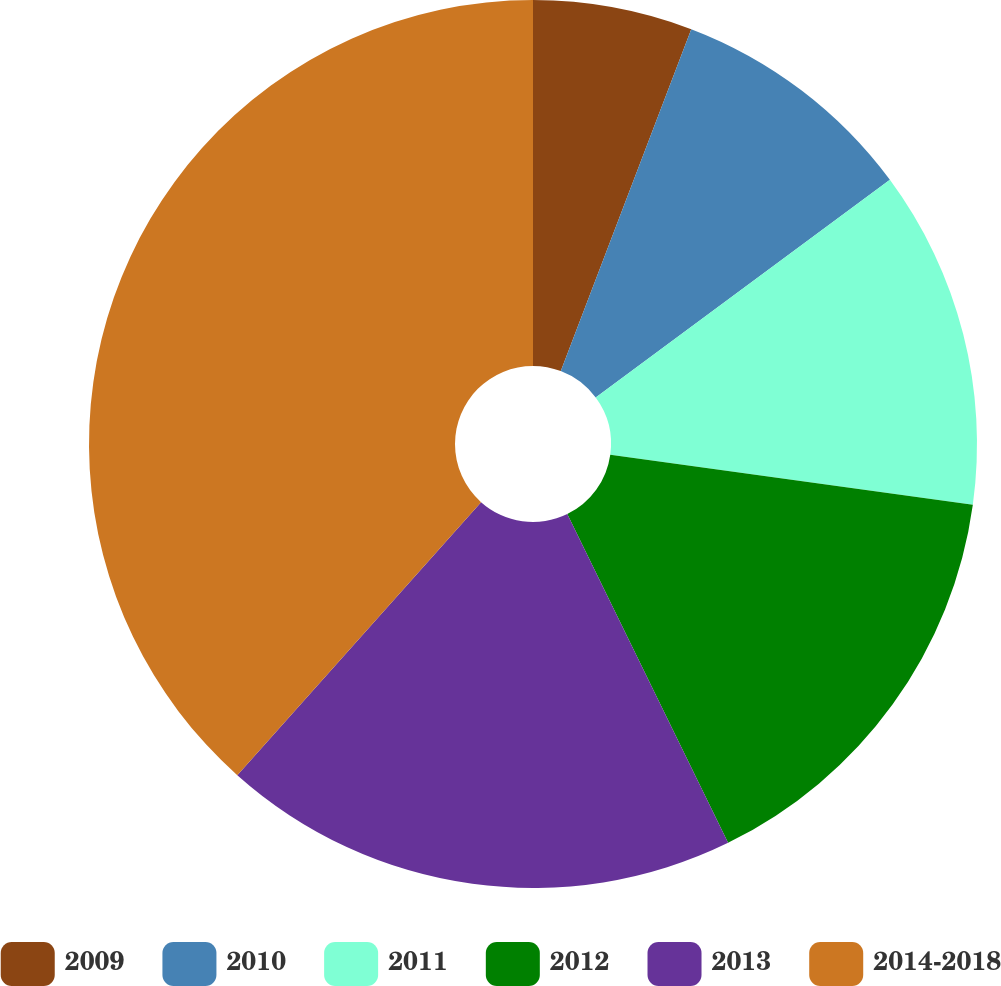Convert chart to OTSL. <chart><loc_0><loc_0><loc_500><loc_500><pie_chart><fcel>2009<fcel>2010<fcel>2011<fcel>2012<fcel>2013<fcel>2014-2018<nl><fcel>5.8%<fcel>9.06%<fcel>12.32%<fcel>15.58%<fcel>18.84%<fcel>38.4%<nl></chart> 